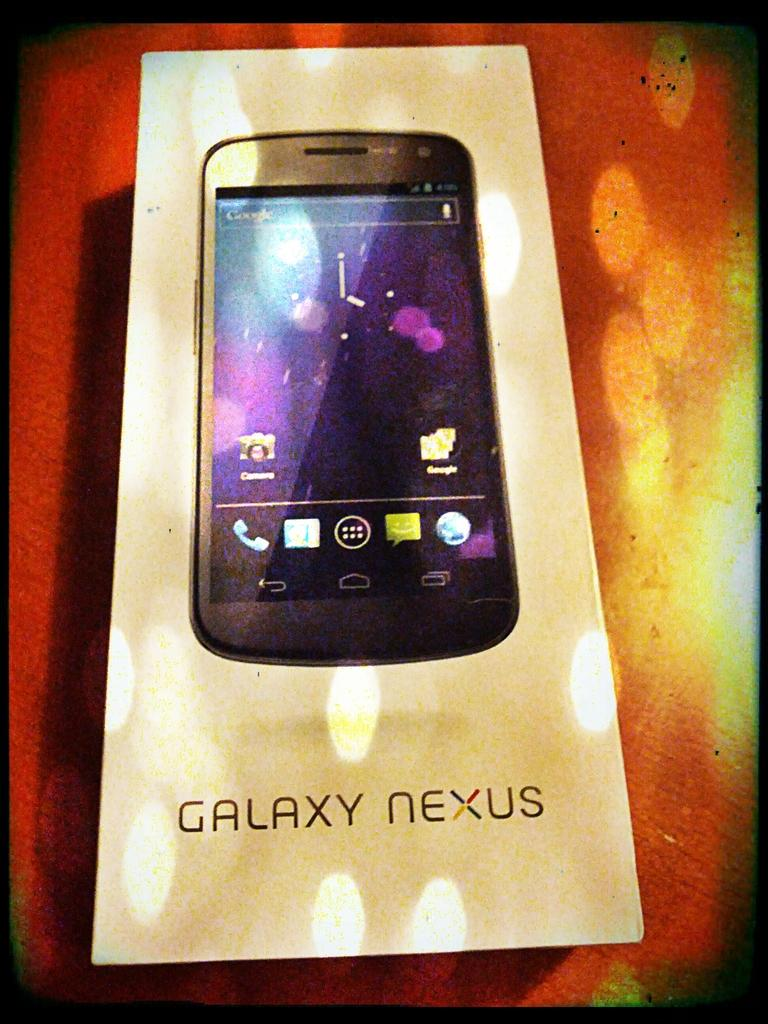<image>
Write a terse but informative summary of the picture. Box showing a black phone and the name "Galaxy Nexus" under it. 